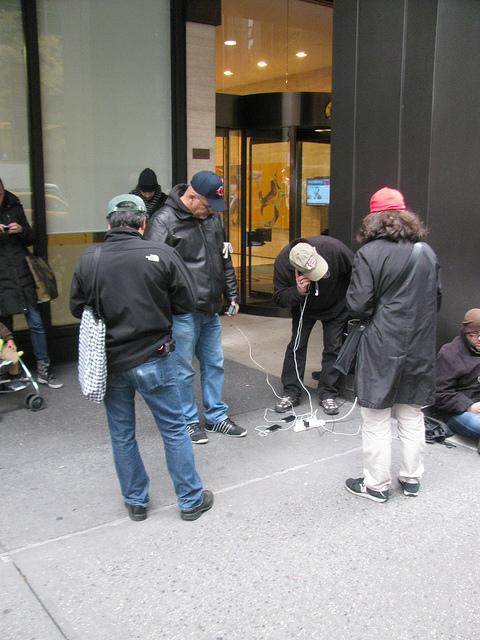Are these people outside?
Short answer required. Yes. How many of them are wearing baseball caps?
Keep it brief. 4. Where is the bench?
Answer briefly. No bench. Where are the phones?
Quick response, please. On ground. 